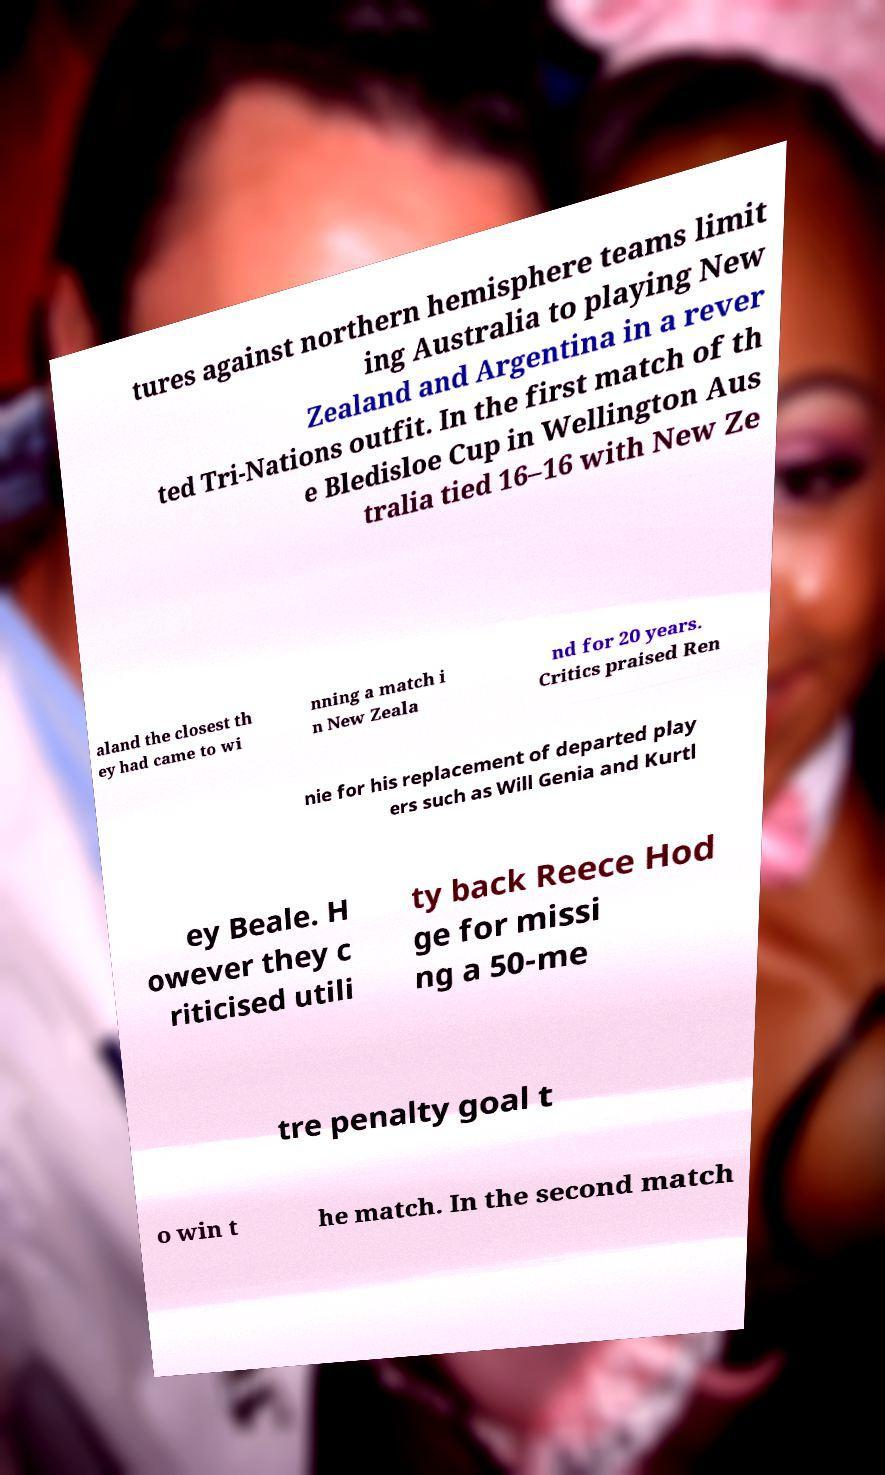Can you accurately transcribe the text from the provided image for me? tures against northern hemisphere teams limit ing Australia to playing New Zealand and Argentina in a rever ted Tri-Nations outfit. In the first match of th e Bledisloe Cup in Wellington Aus tralia tied 16–16 with New Ze aland the closest th ey had came to wi nning a match i n New Zeala nd for 20 years. Critics praised Ren nie for his replacement of departed play ers such as Will Genia and Kurtl ey Beale. H owever they c riticised utili ty back Reece Hod ge for missi ng a 50-me tre penalty goal t o win t he match. In the second match 